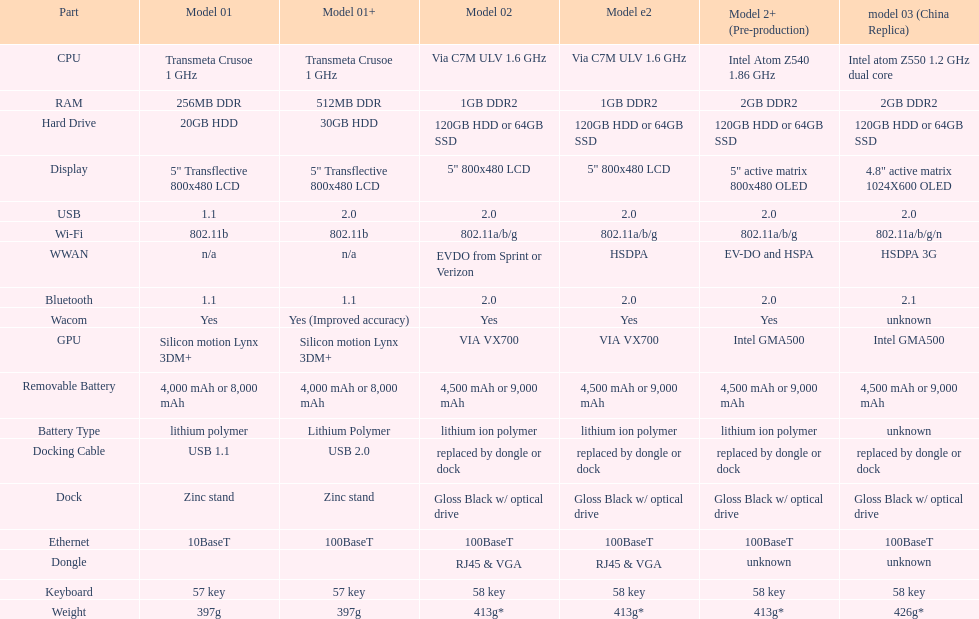What is the total number of components on the chart? 18. 